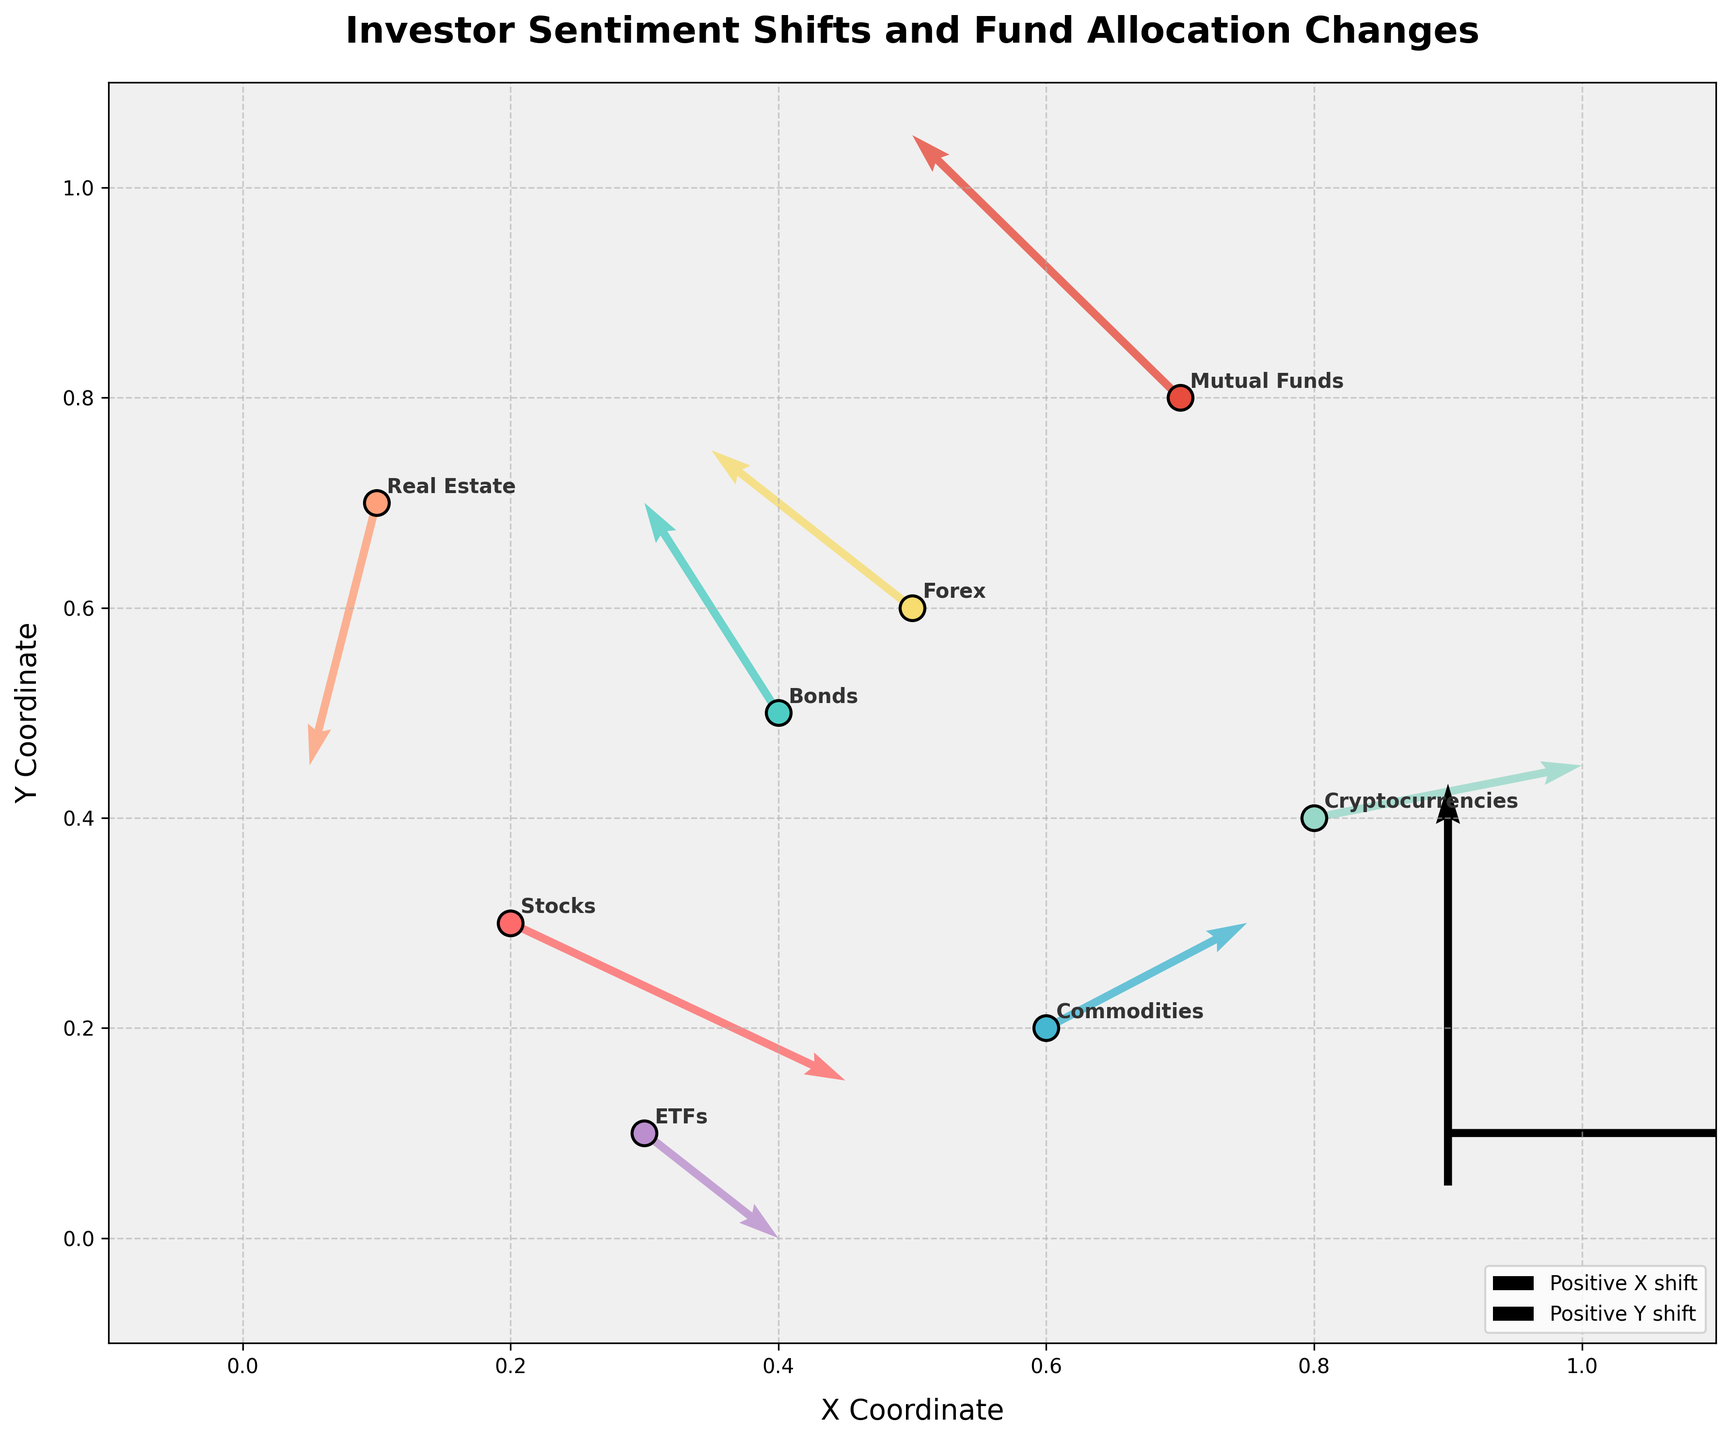What is the title of the plot? The title is usually placed at the top of the plot and is often styled to be more prominent and readable. In this plot, the title reads: "Investor Sentiment Shifts and Fund Allocation Changes".
Answer: Investor Sentiment Shifts and Fund Allocation Changes Which asset class shows a positive shift in both the x and y directions? Look at each arrow's direction to determine the shifts. An arrow pointing right indicates a positive x shift, and one pointing up indicates a positive y shift. Commodities show a positive shift in both the x (0.03) and y (0.02) directions.
Answer: Commodities Which asset class experiences the largest negative y shift? Determine the largest negative v value. Real Estate has a v value of -0.05, the largest negative shift.
Answer: Real Estate How many asset classes are represented in the plot? The number of asset classes can be counted based on the markers and labels shown on the plot. There are eight asset classes: Stocks, Bonds, Commodities, Real Estate, Cryptocurrencies, Forex, ETFs, Mutual Funds.
Answer: 8 Which asset class shows no change in the x direction? Find the arrow with a u value of 0. Forex has a u value of -0.03, meaning no change in the x direction.
Answer: None Compare the shifts for Stocks and Bonds. Which asset class shows a positive shift in the y direction? Check the arrows for both Stocks and Bonds. Stocks have a v value of -0.03, and Bonds have a v value of 0.04. Only Bonds show a positive shift in the y direction.
Answer: Bonds What is the general trend for Cryptocurrencies in terms of shifts? For Cryptocurrencies, the arrow shows u = 0.04 and v = 0.01, indicating a positive shift in both the x and y directions.
Answer: Positive shifts in x and y Identify the asset class closest to the point (0.5, 0.6). Determine which marker is closest to the coordinates (0.5, 0.6). Forex is at (0.5, 0.6).
Answer: Forex What does the legend explain in this plot? The legend in the lower right corner explains arrow directions. It shows "Positive X shift" and "Positive Y shift" using sample arrows.
Answer: Arrow directions Which asset class shows the least movement overall (considering both x and y shifts)? For least movement, look for the smallest combined change in u and v values. Stocks have the smallest movement overall with u = 0.05 and v = -0.03.
Answer: Stocks 